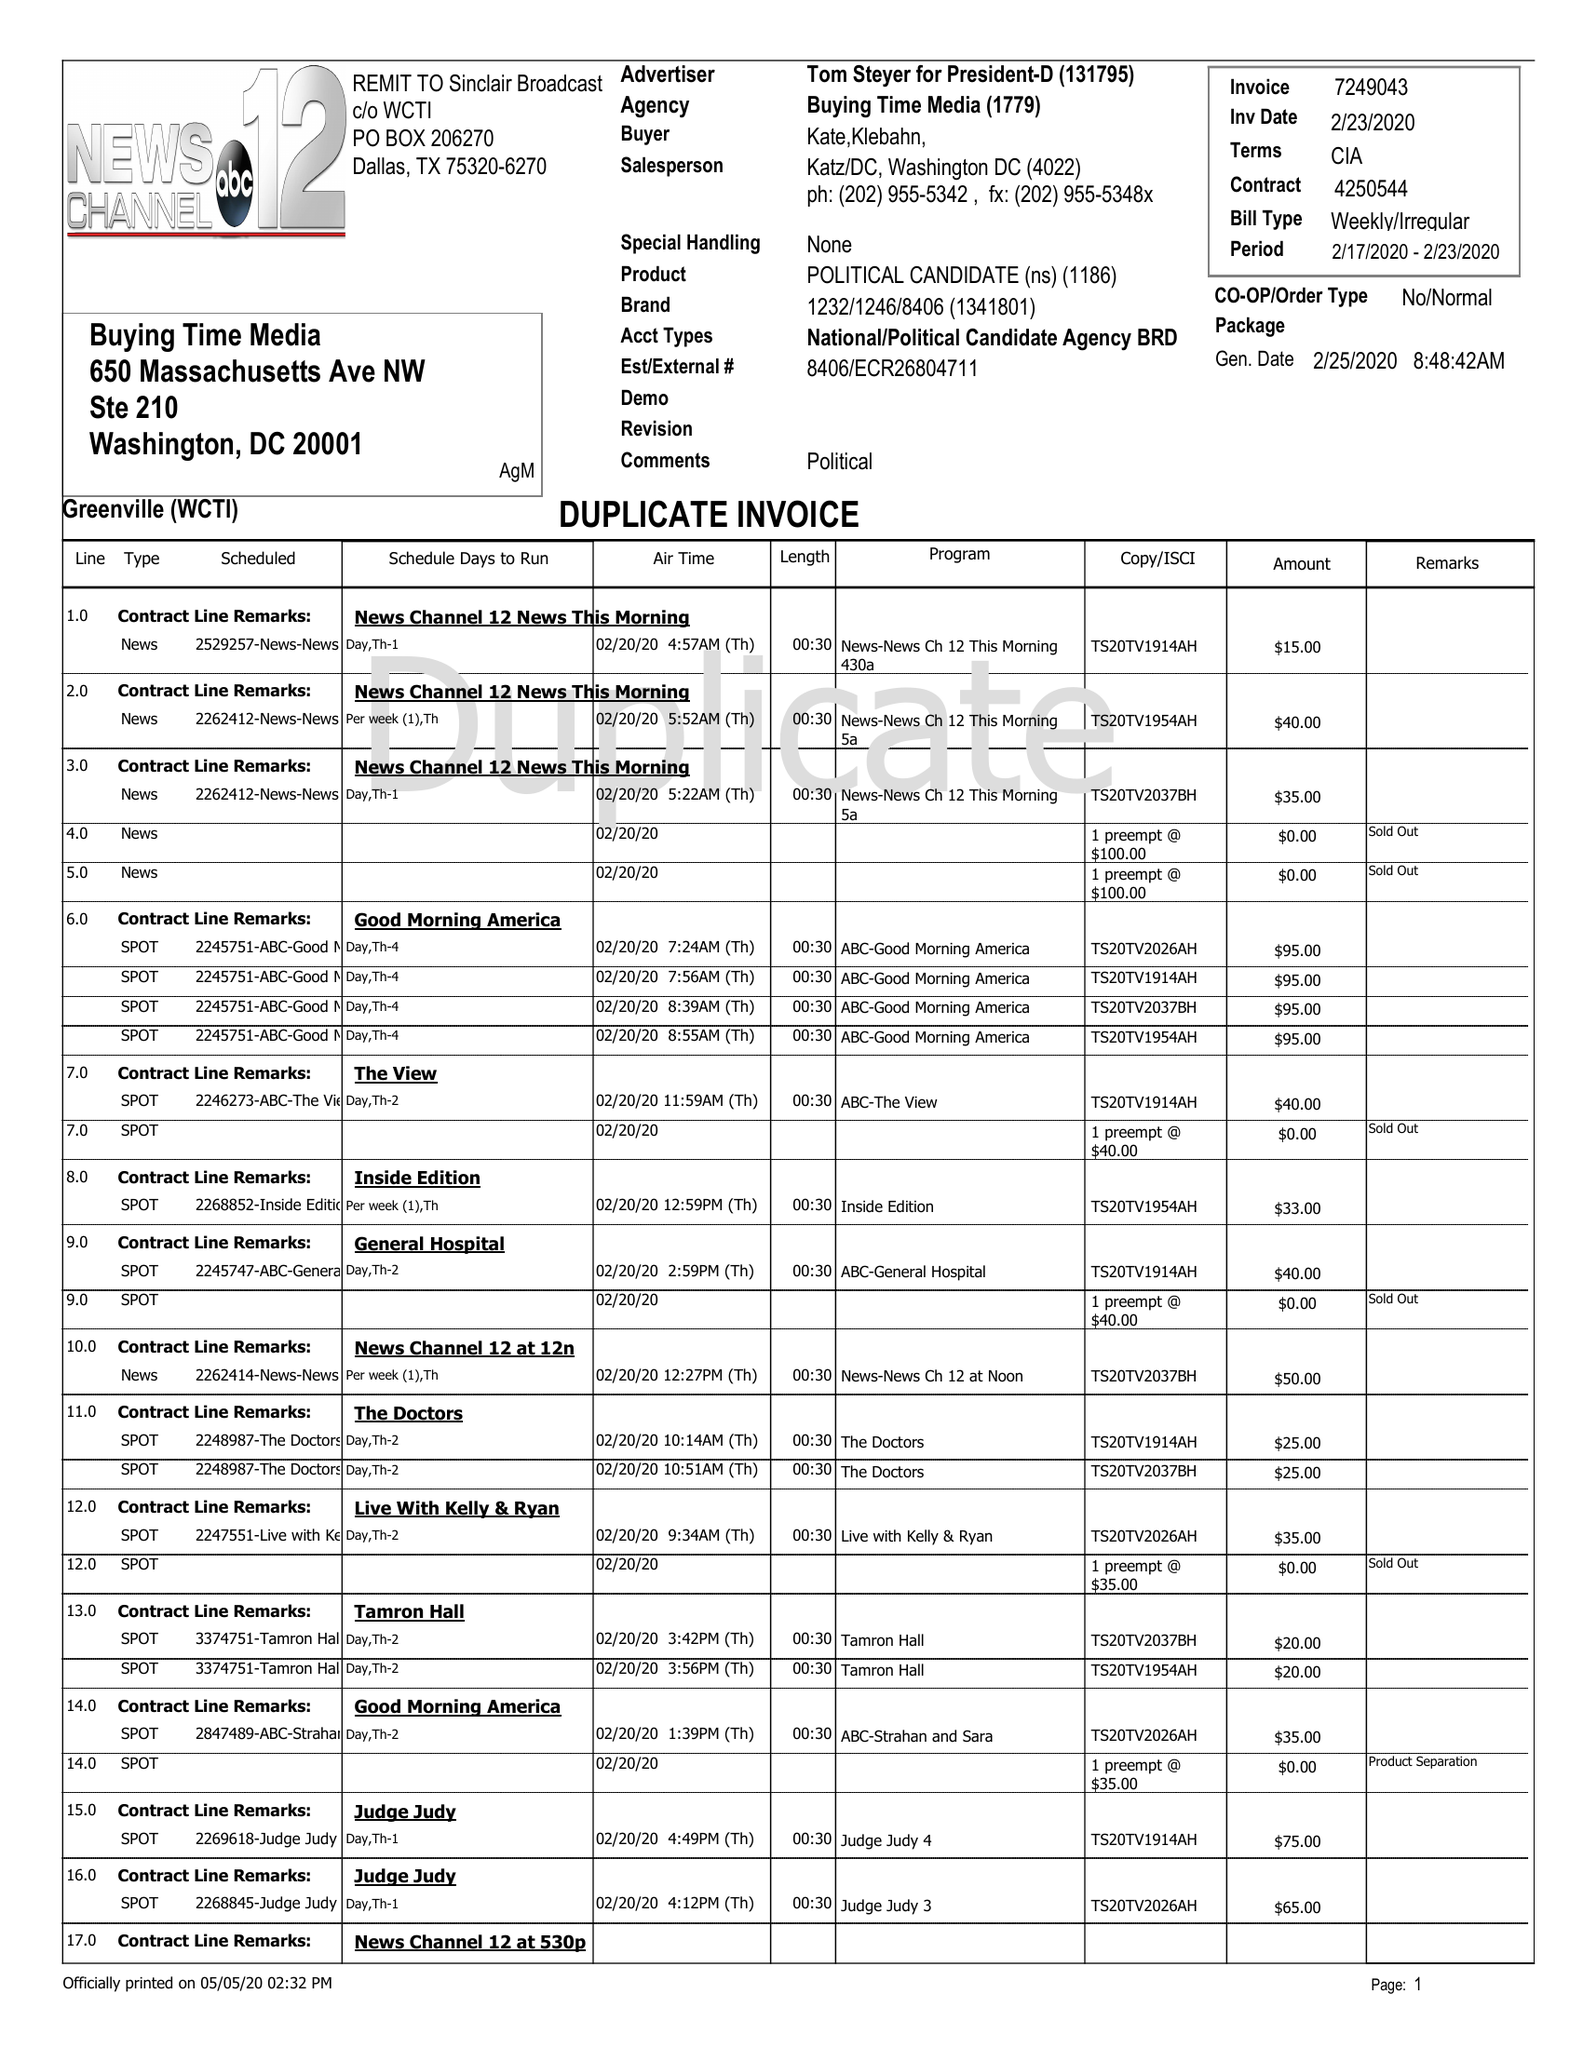What is the value for the gross_amount?
Answer the question using a single word or phrase. 6414.00 